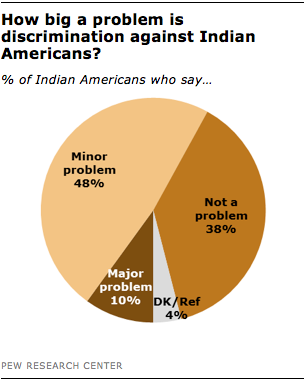Specify some key components in this picture. The ratio between minor problems and not a problems is 1.26315... The issue represents 0.1% of the overall problem. 